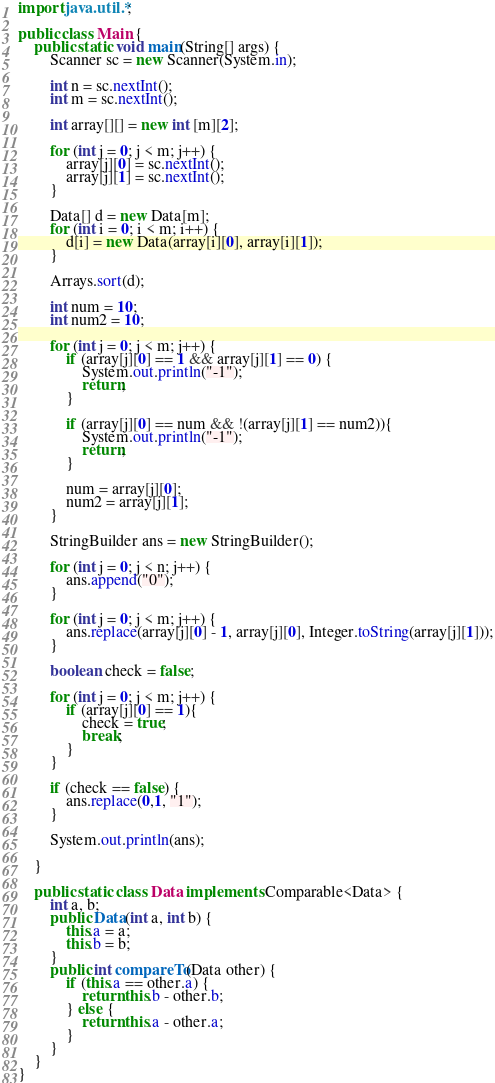Convert code to text. <code><loc_0><loc_0><loc_500><loc_500><_Java_>import java.util.*;

public class Main {
    public static void main(String[] args) {
        Scanner sc = new Scanner(System.in);

        int n = sc.nextInt();
        int m = sc.nextInt();

        int array[][] = new int [m][2];

        for (int j = 0; j < m; j++) {
            array[j][0] = sc.nextInt();
            array[j][1] = sc.nextInt();
        }

        Data[] d = new Data[m];
        for (int i = 0; i < m; i++) {
            d[i] = new Data(array[i][0], array[i][1]);
        }

        Arrays.sort(d);

        int num = 10;
        int num2 = 10;

        for (int j = 0; j < m; j++) {
            if (array[j][0] == 1 && array[j][1] == 0) {
                System.out.println("-1");
                return;
            }

            if (array[j][0] == num && !(array[j][1] == num2)){
                System.out.println("-1");
                return;
            }

            num = array[j][0];
            num2 = array[j][1];
        }

        StringBuilder ans = new StringBuilder();

        for (int j = 0; j < n; j++) {
            ans.append("0");
        }

        for (int j = 0; j < m; j++) {
            ans.replace(array[j][0] - 1, array[j][0], Integer.toString(array[j][1]));
        }

        boolean check = false;

        for (int j = 0; j < m; j++) {
            if (array[j][0] == 1){
                check = true;
                break;
            }
        }

        if (check == false) {
            ans.replace(0,1, "1");
        }

        System.out.println(ans);

    }

    public static class Data implements Comparable<Data> {
        int a, b;
        public Data(int a, int b) {
            this.a = a;
            this.b = b;
        }
        public int compareTo(Data other) {
            if (this.a == other.a) {
                return this.b - other.b;
            } else {
                return this.a - other.a;
            }
        }
    }
}
</code> 